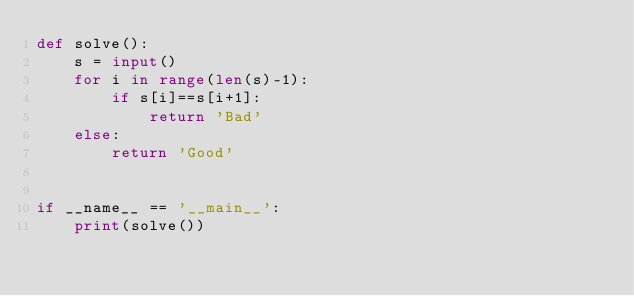<code> <loc_0><loc_0><loc_500><loc_500><_Python_>def solve():
    s = input()
    for i in range(len(s)-1):
        if s[i]==s[i+1]:
            return 'Bad'
    else:
        return 'Good'
        

if __name__ == '__main__':
    print(solve())</code> 